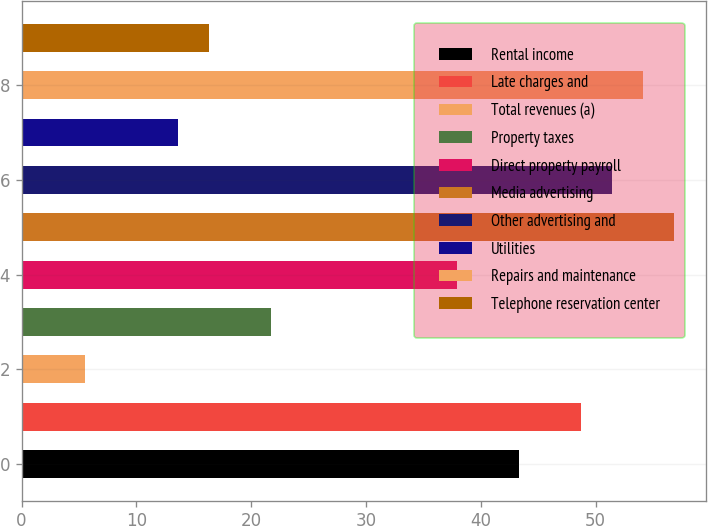<chart> <loc_0><loc_0><loc_500><loc_500><bar_chart><fcel>Rental income<fcel>Late charges and<fcel>Total revenues (a)<fcel>Property taxes<fcel>Direct property payroll<fcel>Media advertising<fcel>Other advertising and<fcel>Utilities<fcel>Repairs and maintenance<fcel>Telephone reservation center<nl><fcel>43.3<fcel>48.7<fcel>5.5<fcel>21.7<fcel>37.9<fcel>56.8<fcel>51.4<fcel>13.6<fcel>54.1<fcel>16.3<nl></chart> 